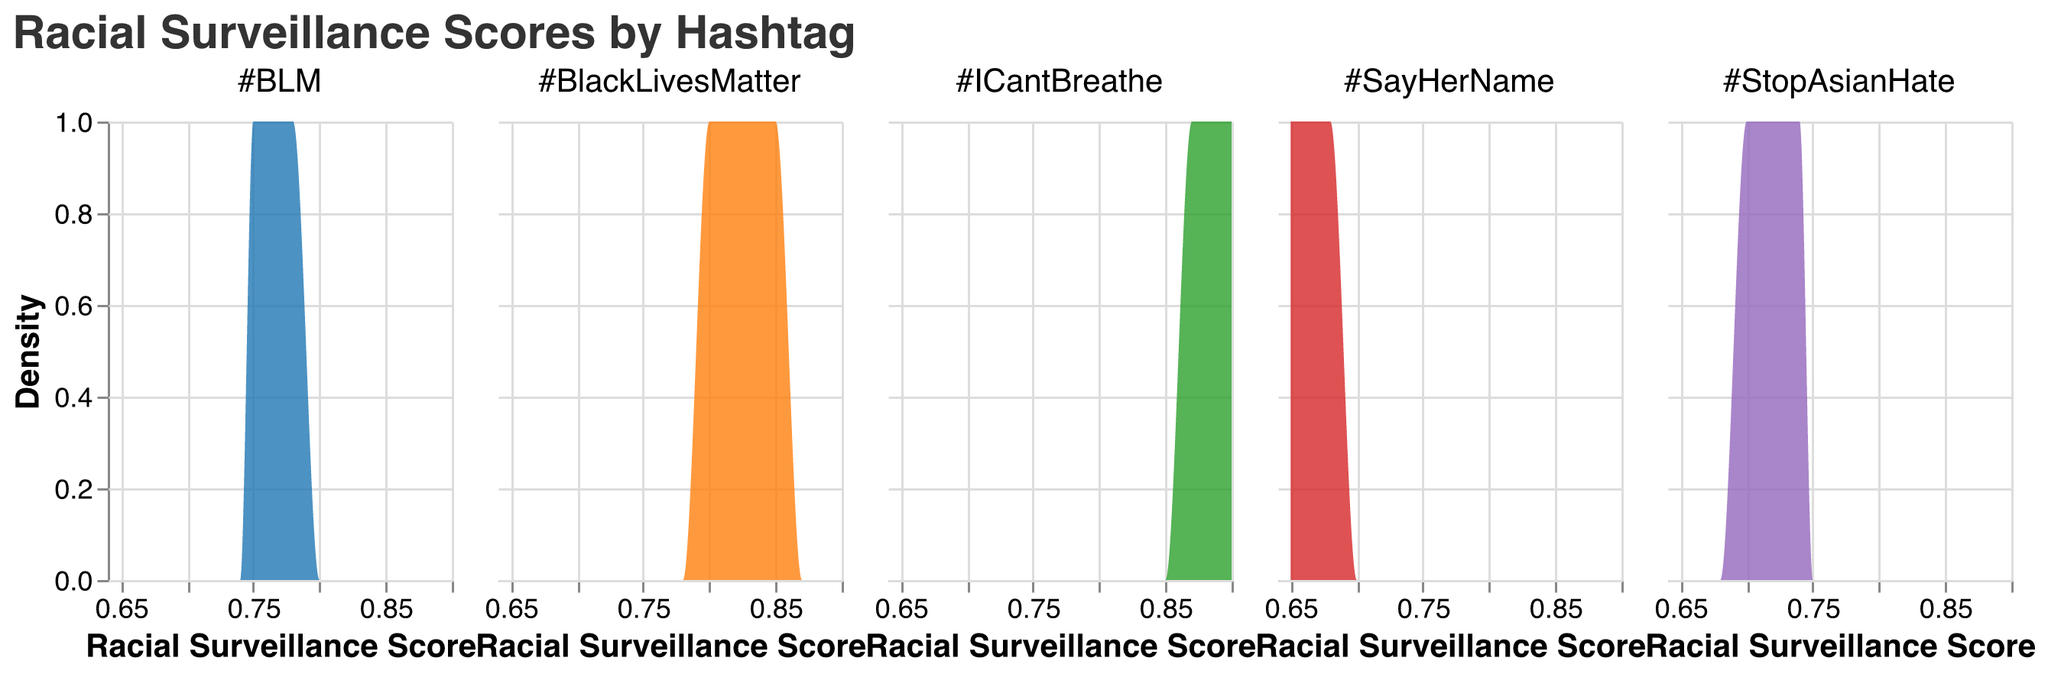What's the title of the figure? The title is located at the top of the figure, written in a larger font. It is common to include the main subject or finding of the plot here.
Answer: "Racial Surveillance Scores by Hashtag" What is the x-axis representing? The x-axis is labeled "Racial Surveillance Score" and shows numerical values, indicating that it measures racial surveillance scores.
Answer: Racial Surveillance Score What do the different colors in the plot represent? The legend associated with the plot or the facet header indicates that different colors are used to differentiate between the hashtags. Each color represents a different hashtag such as #BlackLivesMatter, #BLM, #StopAsianHate, #SayHerName, and #ICantBreathe.
Answer: Different hashtags Which hashtag appears to have the highest density of racial surveillance scores around the 0.9 mark? To find this, observe the density peaks across different colored areas at the 0.9 mark on the x-axis. #ICantBreathe shows a peak near 0.9, suggesting it has a high density in this range.
Answer: #ICantBreathe Are there any hashtags that show very low racial surveillance scores (e.g., below 0.7)? To determine this, look at the beginning of the x-axis (below 0.7) and see if any density curves start in this region. Hashtags like #SayHerName and #StopAsianHate have curves starting below 0.7.
Answer: Yes, #SayHerName and #StopAsianHate On which date does the hashtag #BlackLivesMatter have the highest racial surveillance score? By examining the values or density peaks of #BlackLivesMatter, we see that the highest density peak corresponds to scores around 0.85, focusing on the date 2023-01-04.
Answer: 2023-01-04 What is the relative density of #StopAsianHate compared to #BLM around the score of 0.74? Compare the height of the density curves for both hashtags at the 0.74 mark. The density of #StopAsianHate is higher around 0.74 than that of #BLM, indicating a greater frequency of scores at this value.
Answer: Higher Which hashtag has the most widely spread racial surveillance scores? To determine this, observe the range of the x-axis covered by each hashtag's density curve. #BlackLivesMatter spans a broad range from ~0.7 to ~0.85.
Answer: #BlackLivesMatter Is there any hashtag that consistently shows high racial surveillance scores (above 0.8)? Analyze the areas of each hashtag's density curves above the 0.8 mark. Both #BlackLivesMatter and #ICantBreathe show consistent densities above 0.8, indicating high scores.
Answer: Yes, #BlackLivesMatter and #ICantBreathe 